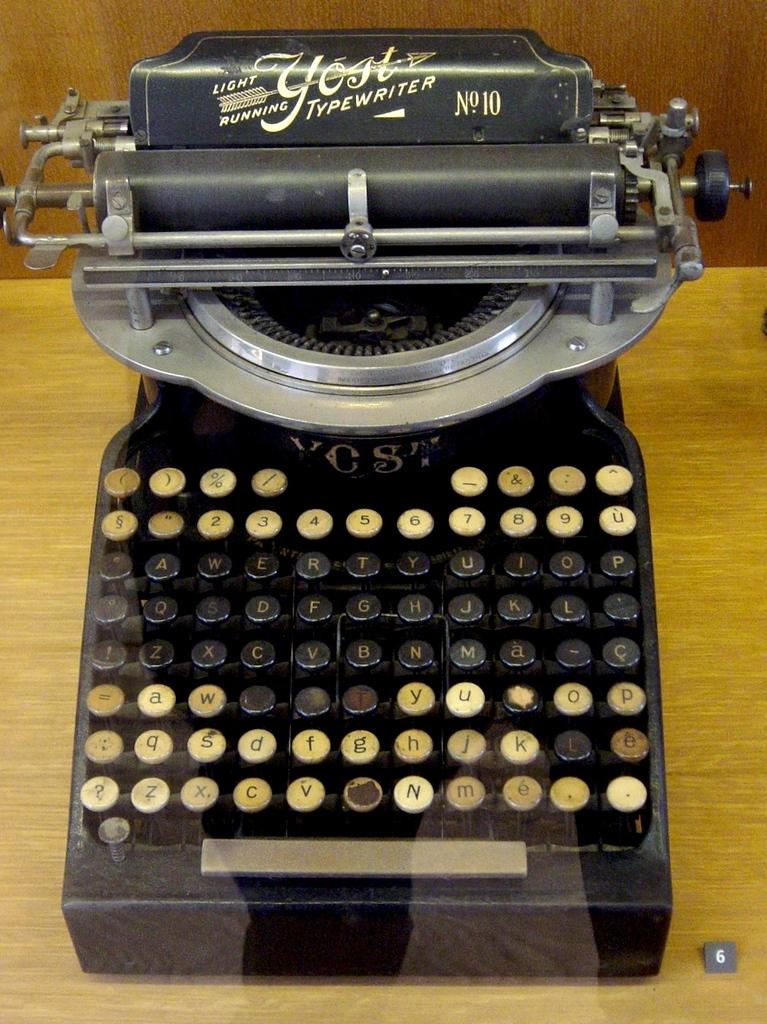What is the main object in the image? There is a typewriter in the image. Where is the typewriter located? The typewriter is placed on a table. What type of verse is being written on the typewriter in the image? There is no verse being written on the typewriter in the image, as it is not actively being used. What type of business is being conducted with the typewriter in the image? There is no indication of any business being conducted with the typewriter in the image, as it is not actively being used. 